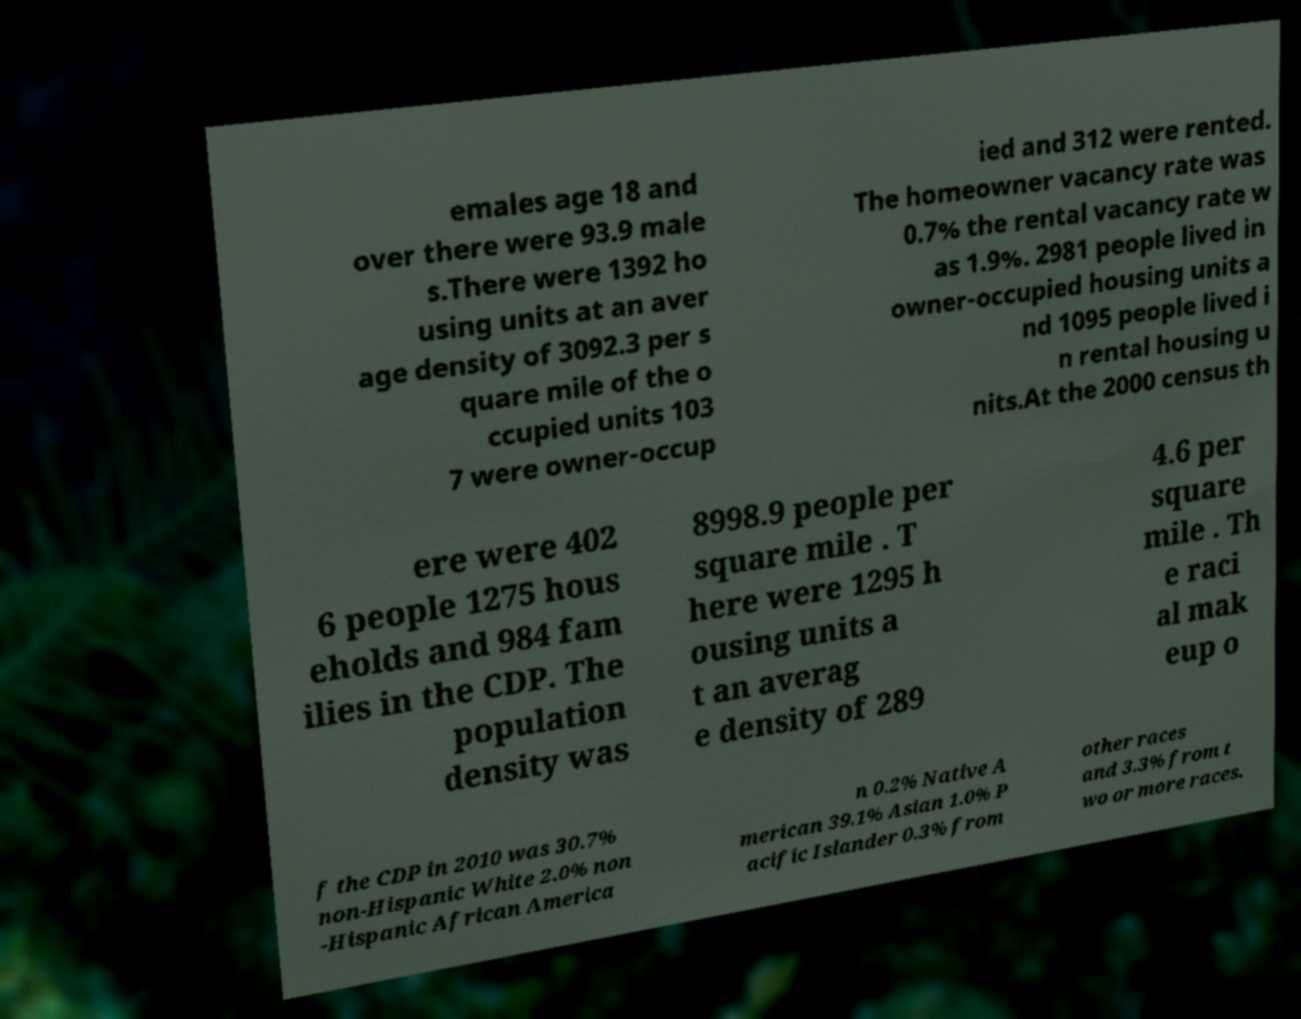Could you assist in decoding the text presented in this image and type it out clearly? emales age 18 and over there were 93.9 male s.There were 1392 ho using units at an aver age density of 3092.3 per s quare mile of the o ccupied units 103 7 were owner-occup ied and 312 were rented. The homeowner vacancy rate was 0.7% the rental vacancy rate w as 1.9%. 2981 people lived in owner-occupied housing units a nd 1095 people lived i n rental housing u nits.At the 2000 census th ere were 402 6 people 1275 hous eholds and 984 fam ilies in the CDP. The population density was 8998.9 people per square mile . T here were 1295 h ousing units a t an averag e density of 289 4.6 per square mile . Th e raci al mak eup o f the CDP in 2010 was 30.7% non-Hispanic White 2.0% non -Hispanic African America n 0.2% Native A merican 39.1% Asian 1.0% P acific Islander 0.3% from other races and 3.3% from t wo or more races. 